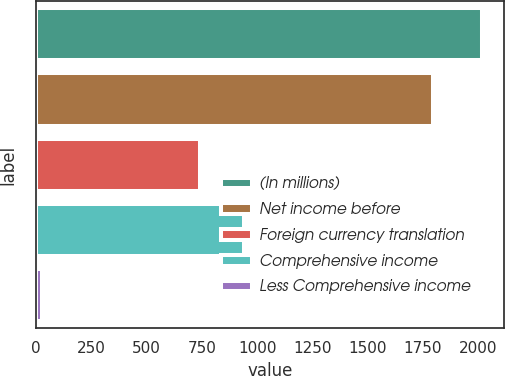<chart> <loc_0><loc_0><loc_500><loc_500><bar_chart><fcel>(In millions)<fcel>Net income before<fcel>Foreign currency translation<fcel>Comprehensive income<fcel>Less Comprehensive income<nl><fcel>2016<fcel>1795<fcel>742<fcel>940.9<fcel>27<nl></chart> 